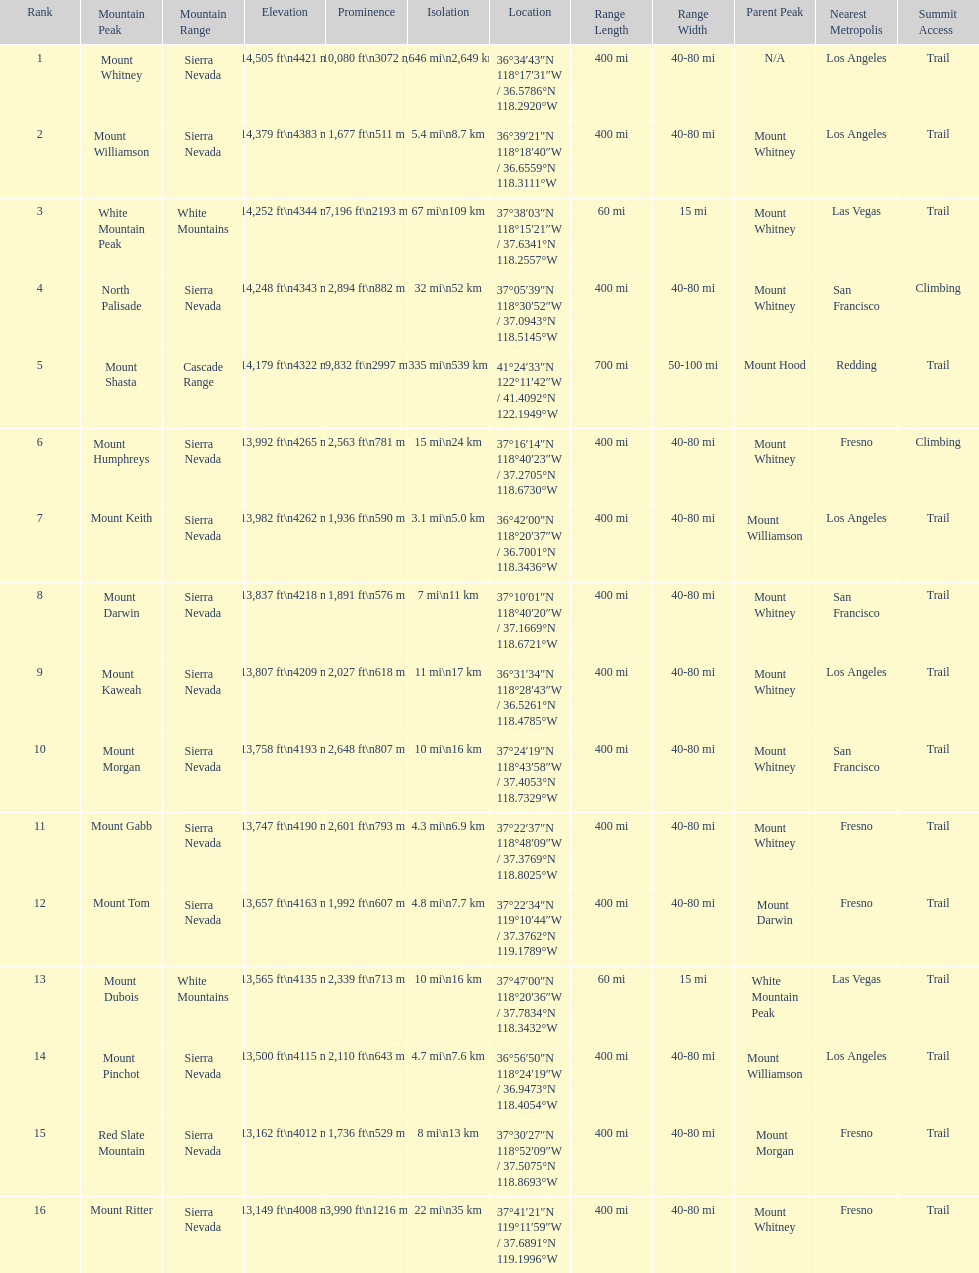Which mountain peak has a prominence more than 10,000 ft? Mount Whitney. Could you parse the entire table? {'header': ['Rank', 'Mountain Peak', 'Mountain Range', 'Elevation', 'Prominence', 'Isolation', 'Location', 'Range Length', 'Range Width', 'Parent Peak', 'Nearest Metropolis', 'Summit Access'], 'rows': [['1', 'Mount Whitney', 'Sierra Nevada', '14,505\xa0ft\\n4421\xa0m', '10,080\xa0ft\\n3072\xa0m', '1,646\xa0mi\\n2,649\xa0km', '36°34′43″N 118°17′31″W\ufeff / \ufeff36.5786°N 118.2920°W', '400 mi', '40-80 mi', 'N/A', 'Los Angeles', 'Trail'], ['2', 'Mount Williamson', 'Sierra Nevada', '14,379\xa0ft\\n4383\xa0m', '1,677\xa0ft\\n511\xa0m', '5.4\xa0mi\\n8.7\xa0km', '36°39′21″N 118°18′40″W\ufeff / \ufeff36.6559°N 118.3111°W', '400 mi', '40-80 mi', 'Mount Whitney', 'Los Angeles', 'Trail'], ['3', 'White Mountain Peak', 'White Mountains', '14,252\xa0ft\\n4344\xa0m', '7,196\xa0ft\\n2193\xa0m', '67\xa0mi\\n109\xa0km', '37°38′03″N 118°15′21″W\ufeff / \ufeff37.6341°N 118.2557°W', '60 mi', '15 mi', 'Mount Whitney', 'Las Vegas', 'Trail'], ['4', 'North Palisade', 'Sierra Nevada', '14,248\xa0ft\\n4343\xa0m', '2,894\xa0ft\\n882\xa0m', '32\xa0mi\\n52\xa0km', '37°05′39″N 118°30′52″W\ufeff / \ufeff37.0943°N 118.5145°W', '400 mi', '40-80 mi', 'Mount Whitney', 'San Francisco', 'Climbing'], ['5', 'Mount Shasta', 'Cascade Range', '14,179\xa0ft\\n4322\xa0m', '9,832\xa0ft\\n2997\xa0m', '335\xa0mi\\n539\xa0km', '41°24′33″N 122°11′42″W\ufeff / \ufeff41.4092°N 122.1949°W', '700 mi', '50-100 mi', 'Mount Hood', 'Redding', 'Trail'], ['6', 'Mount Humphreys', 'Sierra Nevada', '13,992\xa0ft\\n4265\xa0m', '2,563\xa0ft\\n781\xa0m', '15\xa0mi\\n24\xa0km', '37°16′14″N 118°40′23″W\ufeff / \ufeff37.2705°N 118.6730°W', '400 mi', '40-80 mi', 'Mount Whitney', 'Fresno', 'Climbing'], ['7', 'Mount Keith', 'Sierra Nevada', '13,982\xa0ft\\n4262\xa0m', '1,936\xa0ft\\n590\xa0m', '3.1\xa0mi\\n5.0\xa0km', '36°42′00″N 118°20′37″W\ufeff / \ufeff36.7001°N 118.3436°W', '400 mi', '40-80 mi', 'Mount Williamson', 'Los Angeles', 'Trail'], ['8', 'Mount Darwin', 'Sierra Nevada', '13,837\xa0ft\\n4218\xa0m', '1,891\xa0ft\\n576\xa0m', '7\xa0mi\\n11\xa0km', '37°10′01″N 118°40′20″W\ufeff / \ufeff37.1669°N 118.6721°W', '400 mi', '40-80 mi', 'Mount Whitney', 'San Francisco', 'Trail'], ['9', 'Mount Kaweah', 'Sierra Nevada', '13,807\xa0ft\\n4209\xa0m', '2,027\xa0ft\\n618\xa0m', '11\xa0mi\\n17\xa0km', '36°31′34″N 118°28′43″W\ufeff / \ufeff36.5261°N 118.4785°W', '400 mi', '40-80 mi', 'Mount Whitney', 'Los Angeles', 'Trail'], ['10', 'Mount Morgan', 'Sierra Nevada', '13,758\xa0ft\\n4193\xa0m', '2,648\xa0ft\\n807\xa0m', '10\xa0mi\\n16\xa0km', '37°24′19″N 118°43′58″W\ufeff / \ufeff37.4053°N 118.7329°W', '400 mi', '40-80 mi', 'Mount Whitney', 'San Francisco', 'Trail'], ['11', 'Mount Gabb', 'Sierra Nevada', '13,747\xa0ft\\n4190\xa0m', '2,601\xa0ft\\n793\xa0m', '4.3\xa0mi\\n6.9\xa0km', '37°22′37″N 118°48′09″W\ufeff / \ufeff37.3769°N 118.8025°W', '400 mi', '40-80 mi', 'Mount Whitney', 'Fresno', 'Trail'], ['12', 'Mount Tom', 'Sierra Nevada', '13,657\xa0ft\\n4163\xa0m', '1,992\xa0ft\\n607\xa0m', '4.8\xa0mi\\n7.7\xa0km', '37°22′34″N 119°10′44″W\ufeff / \ufeff37.3762°N 119.1789°W', '400 mi', '40-80 mi', 'Mount Darwin', 'Fresno', 'Trail'], ['13', 'Mount Dubois', 'White Mountains', '13,565\xa0ft\\n4135\xa0m', '2,339\xa0ft\\n713\xa0m', '10\xa0mi\\n16\xa0km', '37°47′00″N 118°20′36″W\ufeff / \ufeff37.7834°N 118.3432°W', '60 mi', '15 mi', 'White Mountain Peak', 'Las Vegas', 'Trail'], ['14', 'Mount Pinchot', 'Sierra Nevada', '13,500\xa0ft\\n4115\xa0m', '2,110\xa0ft\\n643\xa0m', '4.7\xa0mi\\n7.6\xa0km', '36°56′50″N 118°24′19″W\ufeff / \ufeff36.9473°N 118.4054°W', '400 mi', '40-80 mi', 'Mount Williamson', 'Los Angeles', 'Trail'], ['15', 'Red Slate Mountain', 'Sierra Nevada', '13,162\xa0ft\\n4012\xa0m', '1,736\xa0ft\\n529\xa0m', '8\xa0mi\\n13\xa0km', '37°30′27″N 118°52′09″W\ufeff / \ufeff37.5075°N 118.8693°W', '400 mi', '40-80 mi', 'Mount Morgan', 'Fresno', 'Trail'], ['16', 'Mount Ritter', 'Sierra Nevada', '13,149\xa0ft\\n4008\xa0m', '3,990\xa0ft\\n1216\xa0m', '22\xa0mi\\n35\xa0km', '37°41′21″N 119°11′59″W\ufeff / \ufeff37.6891°N 119.1996°W', '400 mi', '40-80 mi', 'Mount Whitney', 'Fresno', 'Trail']]} 